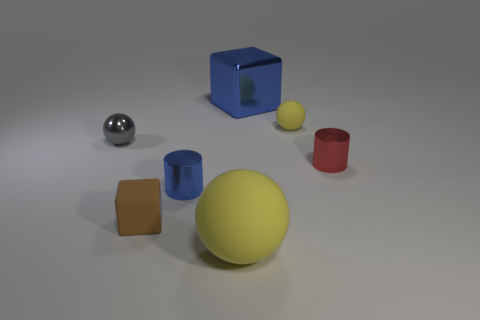Is the shape of the shiny thing behind the tiny gray object the same as  the small gray thing?
Keep it short and to the point. No. Is there any other thing that has the same material as the small block?
Provide a succinct answer. Yes. What number of objects are either cyan metallic blocks or big yellow matte spheres in front of the big blue shiny cube?
Provide a succinct answer. 1. There is a metallic thing that is both on the right side of the large yellow rubber ball and behind the small red metal cylinder; what size is it?
Your answer should be compact. Large. Are there more tiny red metallic cylinders that are behind the small red thing than red cylinders that are on the left side of the brown matte block?
Ensure brevity in your answer.  No. There is a big yellow matte object; is it the same shape as the matte object behind the brown cube?
Offer a terse response. Yes. What number of other objects are the same shape as the small yellow object?
Ensure brevity in your answer.  2. There is a ball that is to the left of the blue metal block and right of the tiny brown matte cube; what color is it?
Provide a succinct answer. Yellow. What color is the rubber block?
Give a very brief answer. Brown. Do the small brown object and the blue object that is in front of the red cylinder have the same material?
Provide a succinct answer. No. 